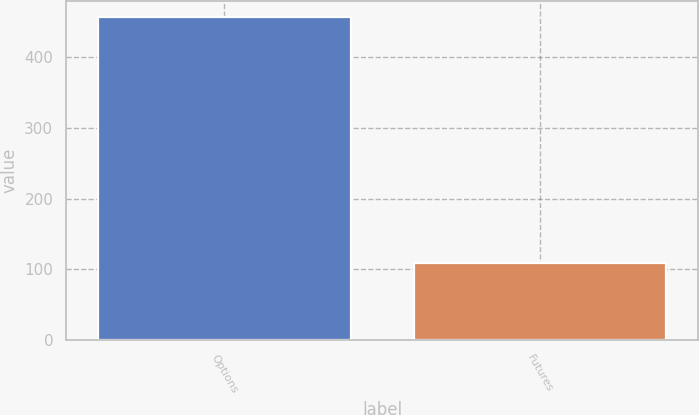Convert chart to OTSL. <chart><loc_0><loc_0><loc_500><loc_500><bar_chart><fcel>Options<fcel>Futures<nl><fcel>457<fcel>109.4<nl></chart> 